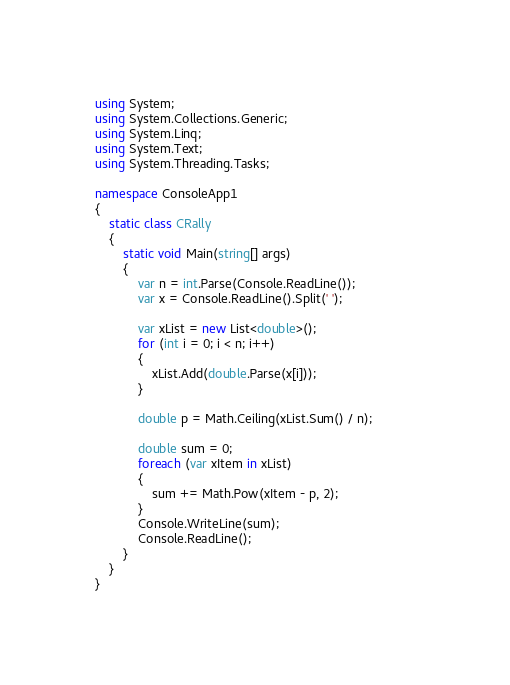Convert code to text. <code><loc_0><loc_0><loc_500><loc_500><_C#_>using System;
using System.Collections.Generic;
using System.Linq;
using System.Text;
using System.Threading.Tasks;

namespace ConsoleApp1
{
    static class CRally
    {
        static void Main(string[] args)
        {
            var n = int.Parse(Console.ReadLine());
            var x = Console.ReadLine().Split(' ');

            var xList = new List<double>();
            for (int i = 0; i < n; i++)
            {
                xList.Add(double.Parse(x[i]));
            }

            double p = Math.Ceiling(xList.Sum() / n);            

            double sum = 0;
            foreach (var xItem in xList)
            {
                sum += Math.Pow(xItem - p, 2);
            }
            Console.WriteLine(sum);
            Console.ReadLine();
        }
    }
}</code> 